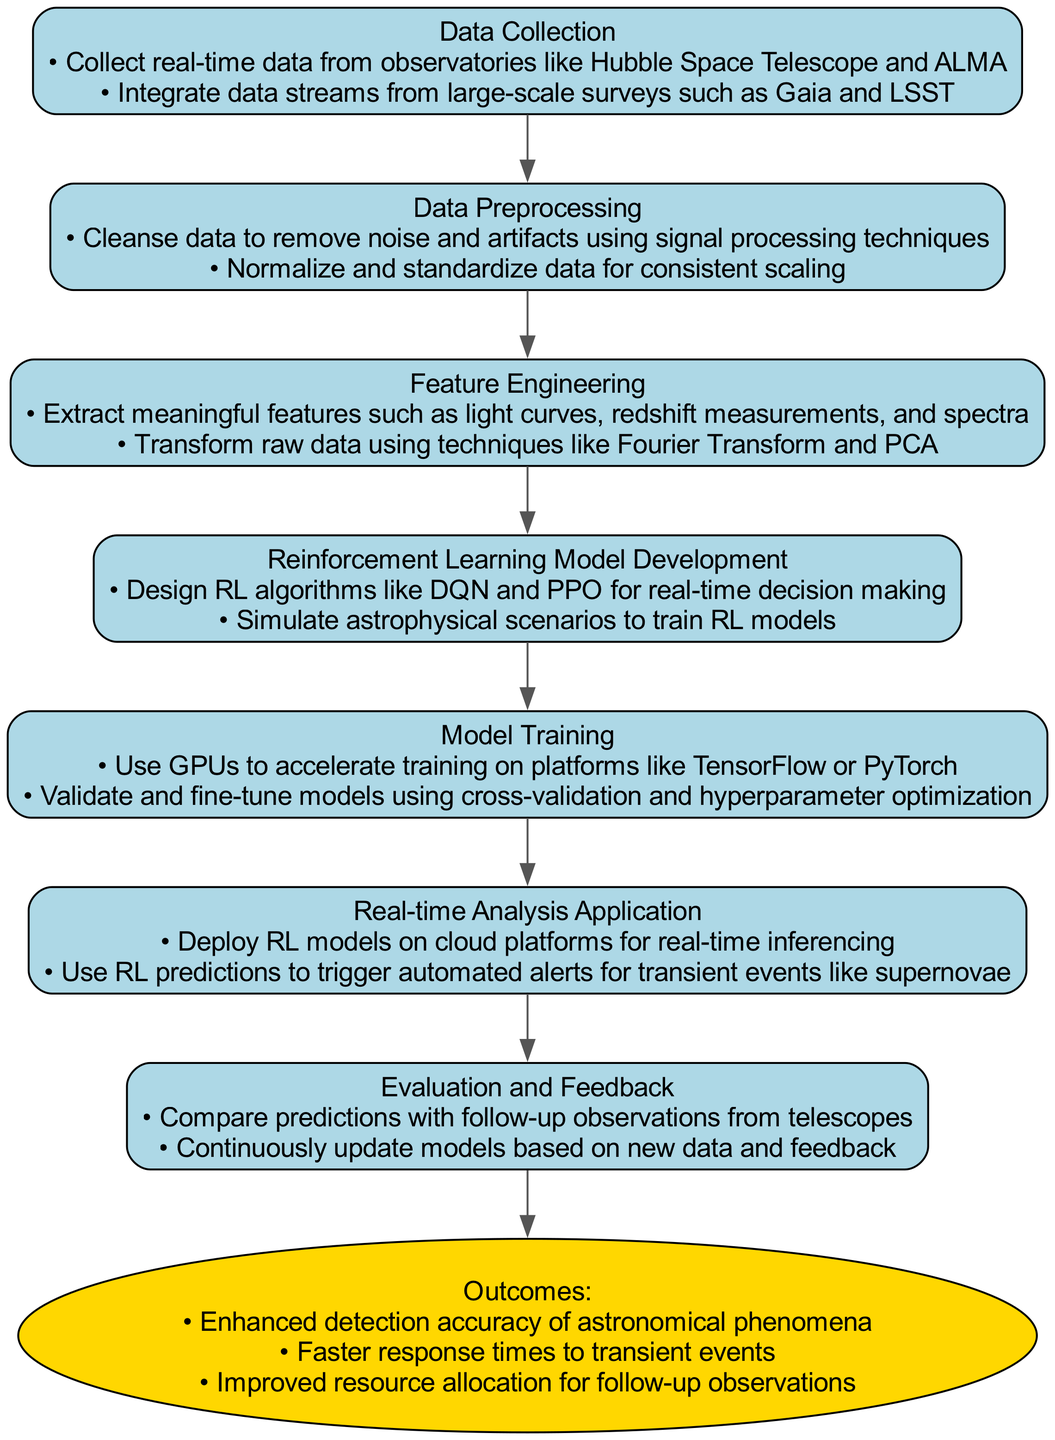What is the first step in the pathway? The first step in the pathway is "Data Collection," which is the initial node in the diagram.
Answer: Data Collection How many actions are listed under "Reinforcement Learning Model Development"? There are two actions listed under "Reinforcement Learning Model Development" in the diagram.
Answer: Two What outcome is related to response times for transient events? The outcome related to response times is "Faster response times to transient events." This can be found in the outcomes section at the end of the pathway.
Answer: Faster response times to transient events Which step precedes "Model Training"? "Reinforcement Learning Model Development" precedes "Model Training" in the flow of the diagram, as seen by the directed edge connecting these two nodes.
Answer: Reinforcement Learning Model Development How many total steps are there in the clinical pathway? The diagram indicates there are seven total steps in the clinical pathway. This includes all the actions taken from data collection to evaluation and feedback.
Answer: Seven Which action involves integrating data streams? The action involving integrating data streams is found under the "Data Collection" step, specifically "Integrate data streams from large-scale surveys such as Gaia and LSST."
Answer: Integrate data streams from large-scale surveys such as Gaia and LSST What is the last step before reaching the outcomes? The last step before reaching the outcomes is "Evaluation and Feedback," which comes immediately before the outcomes node in the diagram.
Answer: Evaluation and Feedback What technique is mentioned for cleaning data? The technique mentioned for cleaning data is "signal processing techniques," as listed under the "Data Preprocessing" step in the diagram.
Answer: Signal processing techniques How does the pathway lead to "Improved resource allocation"? The pathway leads to "Improved resource allocation for follow-up observations" as one of the outcomes through a sequence of steps that enhance detection accuracy and response times, ultimately improving resource use.
Answer: Improved resource allocation for follow-up observations 